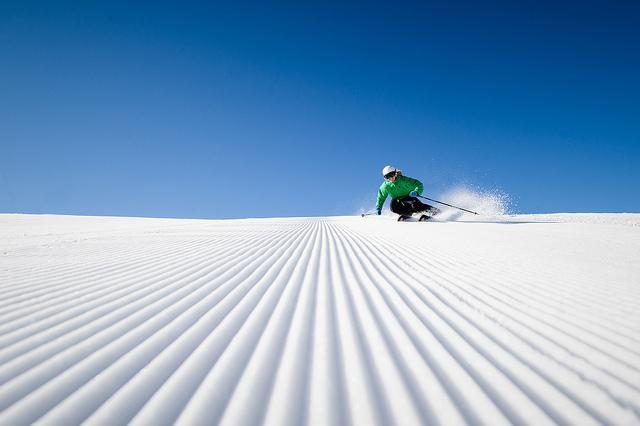How many people are in this photo?
Give a very brief answer. 1. How many of the bears legs are bent?
Give a very brief answer. 0. 